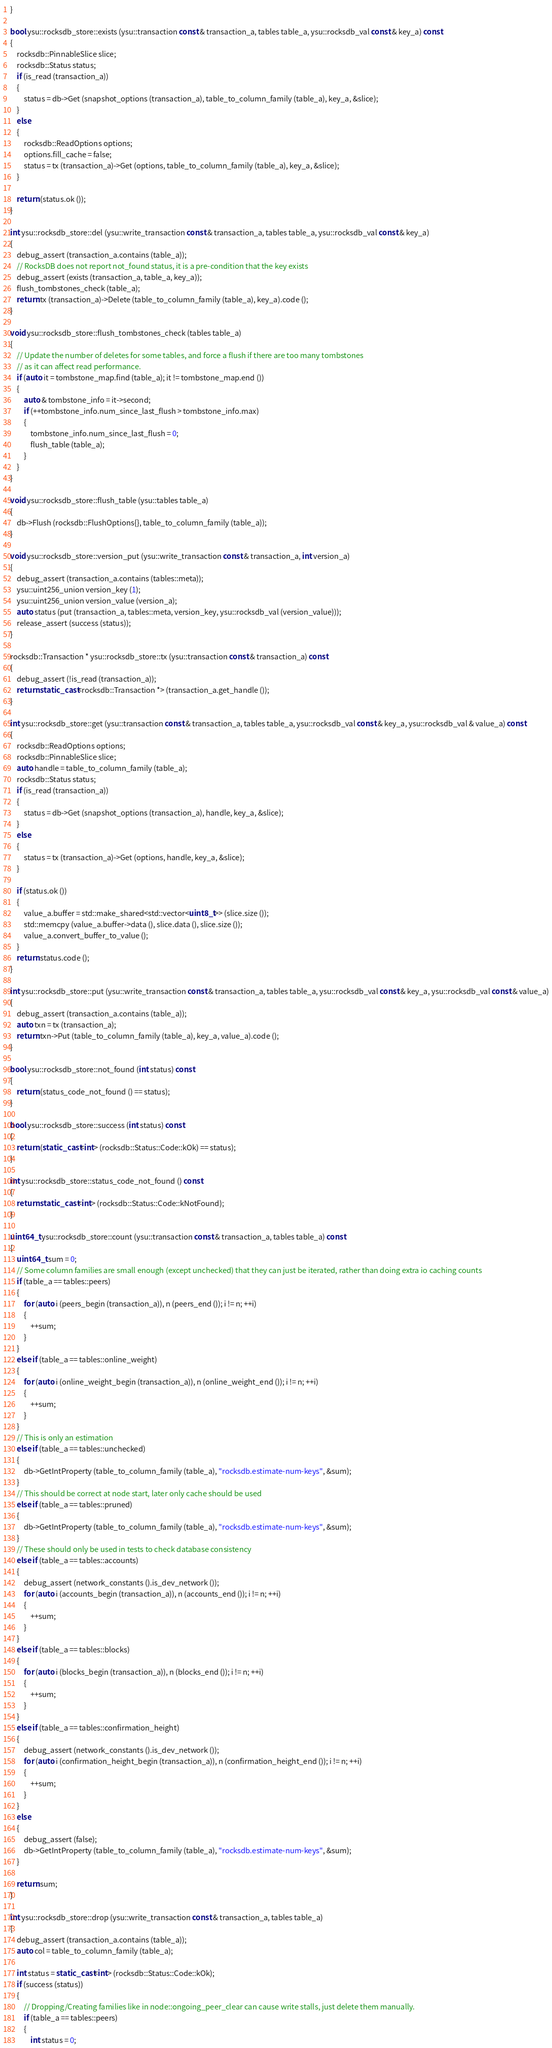Convert code to text. <code><loc_0><loc_0><loc_500><loc_500><_C++_>}

bool ysu::rocksdb_store::exists (ysu::transaction const & transaction_a, tables table_a, ysu::rocksdb_val const & key_a) const
{
	rocksdb::PinnableSlice slice;
	rocksdb::Status status;
	if (is_read (transaction_a))
	{
		status = db->Get (snapshot_options (transaction_a), table_to_column_family (table_a), key_a, &slice);
	}
	else
	{
		rocksdb::ReadOptions options;
		options.fill_cache = false;
		status = tx (transaction_a)->Get (options, table_to_column_family (table_a), key_a, &slice);
	}

	return (status.ok ());
}

int ysu::rocksdb_store::del (ysu::write_transaction const & transaction_a, tables table_a, ysu::rocksdb_val const & key_a)
{
	debug_assert (transaction_a.contains (table_a));
	// RocksDB does not report not_found status, it is a pre-condition that the key exists
	debug_assert (exists (transaction_a, table_a, key_a));
	flush_tombstones_check (table_a);
	return tx (transaction_a)->Delete (table_to_column_family (table_a), key_a).code ();
}

void ysu::rocksdb_store::flush_tombstones_check (tables table_a)
{
	// Update the number of deletes for some tables, and force a flush if there are too many tombstones
	// as it can affect read performance.
	if (auto it = tombstone_map.find (table_a); it != tombstone_map.end ())
	{
		auto & tombstone_info = it->second;
		if (++tombstone_info.num_since_last_flush > tombstone_info.max)
		{
			tombstone_info.num_since_last_flush = 0;
			flush_table (table_a);
		}
	}
}

void ysu::rocksdb_store::flush_table (ysu::tables table_a)
{
	db->Flush (rocksdb::FlushOptions{}, table_to_column_family (table_a));
}

void ysu::rocksdb_store::version_put (ysu::write_transaction const & transaction_a, int version_a)
{
	debug_assert (transaction_a.contains (tables::meta));
	ysu::uint256_union version_key (1);
	ysu::uint256_union version_value (version_a);
	auto status (put (transaction_a, tables::meta, version_key, ysu::rocksdb_val (version_value)));
	release_assert (success (status));
}

rocksdb::Transaction * ysu::rocksdb_store::tx (ysu::transaction const & transaction_a) const
{
	debug_assert (!is_read (transaction_a));
	return static_cast<rocksdb::Transaction *> (transaction_a.get_handle ());
}

int ysu::rocksdb_store::get (ysu::transaction const & transaction_a, tables table_a, ysu::rocksdb_val const & key_a, ysu::rocksdb_val & value_a) const
{
	rocksdb::ReadOptions options;
	rocksdb::PinnableSlice slice;
	auto handle = table_to_column_family (table_a);
	rocksdb::Status status;
	if (is_read (transaction_a))
	{
		status = db->Get (snapshot_options (transaction_a), handle, key_a, &slice);
	}
	else
	{
		status = tx (transaction_a)->Get (options, handle, key_a, &slice);
	}

	if (status.ok ())
	{
		value_a.buffer = std::make_shared<std::vector<uint8_t>> (slice.size ());
		std::memcpy (value_a.buffer->data (), slice.data (), slice.size ());
		value_a.convert_buffer_to_value ();
	}
	return status.code ();
}

int ysu::rocksdb_store::put (ysu::write_transaction const & transaction_a, tables table_a, ysu::rocksdb_val const & key_a, ysu::rocksdb_val const & value_a)
{
	debug_assert (transaction_a.contains (table_a));
	auto txn = tx (transaction_a);
	return txn->Put (table_to_column_family (table_a), key_a, value_a).code ();
}

bool ysu::rocksdb_store::not_found (int status) const
{
	return (status_code_not_found () == status);
}

bool ysu::rocksdb_store::success (int status) const
{
	return (static_cast<int> (rocksdb::Status::Code::kOk) == status);
}

int ysu::rocksdb_store::status_code_not_found () const
{
	return static_cast<int> (rocksdb::Status::Code::kNotFound);
}

uint64_t ysu::rocksdb_store::count (ysu::transaction const & transaction_a, tables table_a) const
{
	uint64_t sum = 0;
	// Some column families are small enough (except unchecked) that they can just be iterated, rather than doing extra io caching counts
	if (table_a == tables::peers)
	{
		for (auto i (peers_begin (transaction_a)), n (peers_end ()); i != n; ++i)
		{
			++sum;
		}
	}
	else if (table_a == tables::online_weight)
	{
		for (auto i (online_weight_begin (transaction_a)), n (online_weight_end ()); i != n; ++i)
		{
			++sum;
		}
	}
	// This is only an estimation
	else if (table_a == tables::unchecked)
	{
		db->GetIntProperty (table_to_column_family (table_a), "rocksdb.estimate-num-keys", &sum);
	}
	// This should be correct at node start, later only cache should be used
	else if (table_a == tables::pruned)
	{
		db->GetIntProperty (table_to_column_family (table_a), "rocksdb.estimate-num-keys", &sum);
	}
	// These should only be used in tests to check database consistency
	else if (table_a == tables::accounts)
	{
		debug_assert (network_constants ().is_dev_network ());
		for (auto i (accounts_begin (transaction_a)), n (accounts_end ()); i != n; ++i)
		{
			++sum;
		}
	}
	else if (table_a == tables::blocks)
	{
		for (auto i (blocks_begin (transaction_a)), n (blocks_end ()); i != n; ++i)
		{
			++sum;
		}
	}
	else if (table_a == tables::confirmation_height)
	{
		debug_assert (network_constants ().is_dev_network ());
		for (auto i (confirmation_height_begin (transaction_a)), n (confirmation_height_end ()); i != n; ++i)
		{
			++sum;
		}
	}
	else
	{
		debug_assert (false);
		db->GetIntProperty (table_to_column_family (table_a), "rocksdb.estimate-num-keys", &sum);
	}

	return sum;
}

int ysu::rocksdb_store::drop (ysu::write_transaction const & transaction_a, tables table_a)
{
	debug_assert (transaction_a.contains (table_a));
	auto col = table_to_column_family (table_a);

	int status = static_cast<int> (rocksdb::Status::Code::kOk);
	if (success (status))
	{
		// Dropping/Creating families like in node::ongoing_peer_clear can cause write stalls, just delete them manually.
		if (table_a == tables::peers)
		{
			int status = 0;</code> 